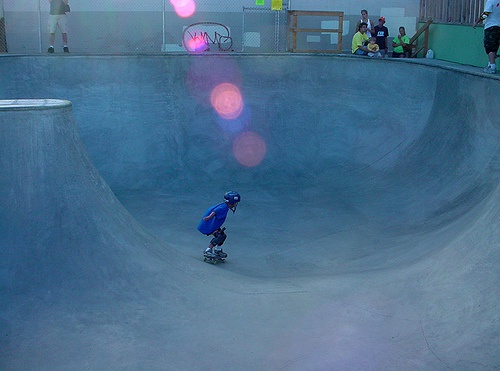Describe the objects in this image and their specific colors. I can see people in gray, navy, black, darkblue, and blue tones, people in gray, black, lightblue, and teal tones, people in gray and blue tones, people in gray, green, black, and navy tones, and people in gray, black, navy, blue, and purple tones in this image. 